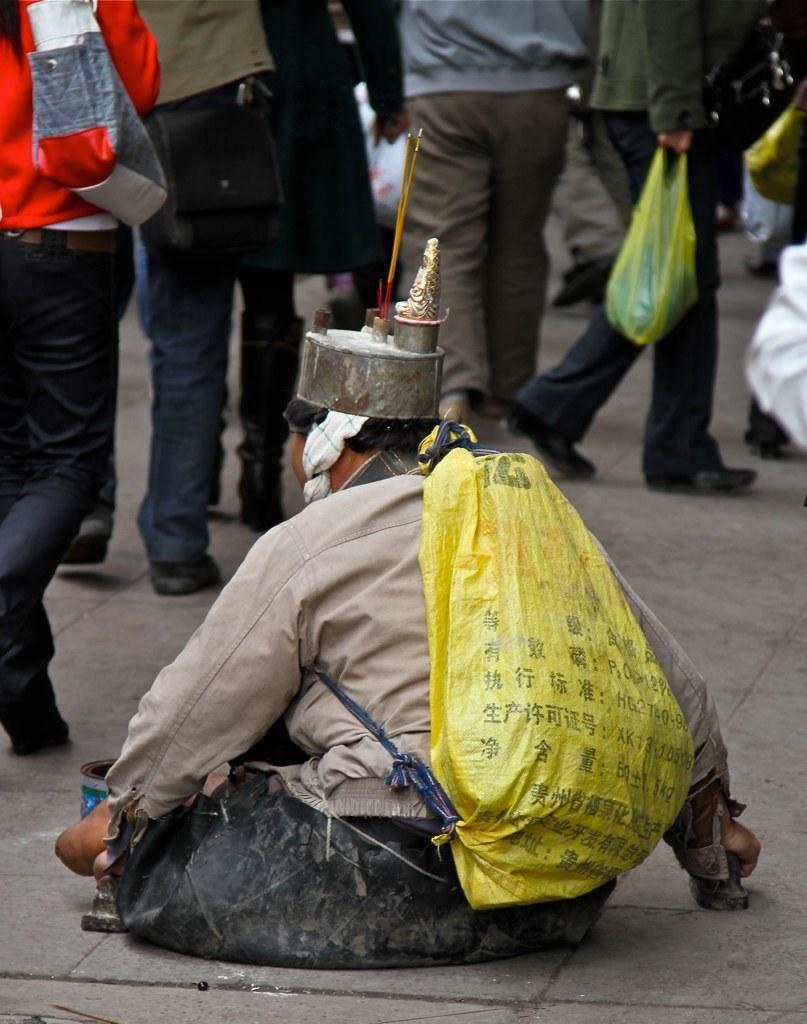Describe this image in one or two sentences. This picture describes about group of people and few people carrying bags. 